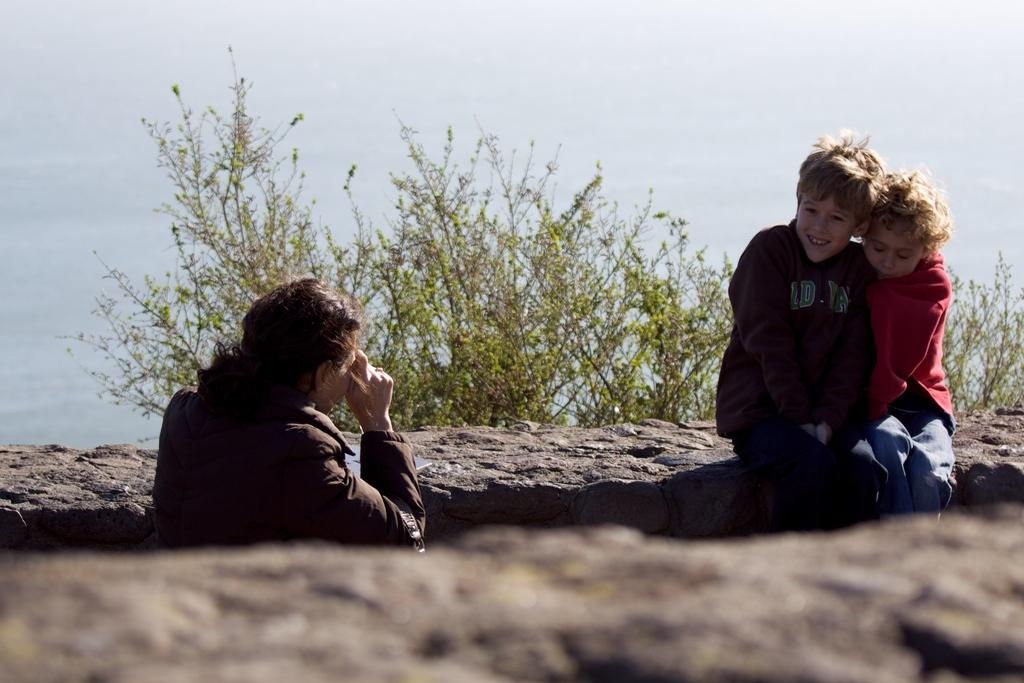What are the kids doing in the image? The kids are sitting on a rock in the image. Who is sitting in front of the kids? There is a man sitting in front of the kids in the image. What can be seen in the background of the image? There are trees visible in the background of the image. What type of bread is the wren eating in the image? There is no bread or wren present in the image. 